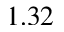Convert formula to latex. <formula><loc_0><loc_0><loc_500><loc_500>1 . 3 2</formula> 